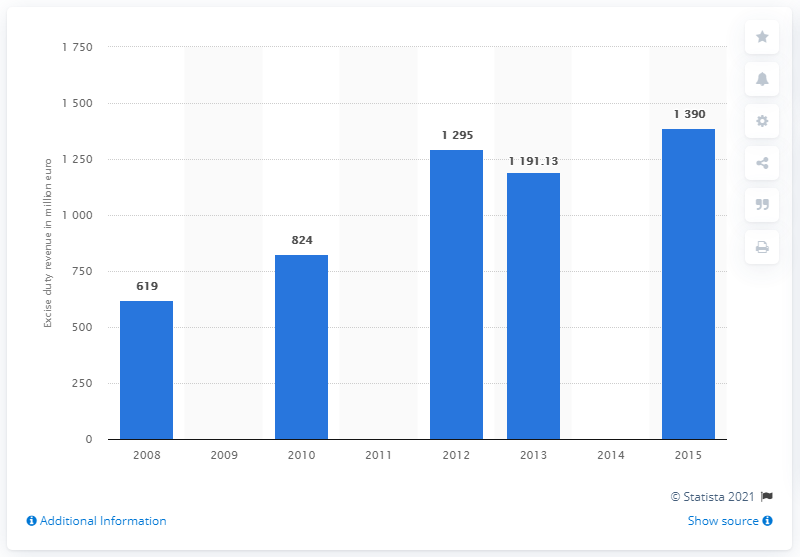Highlight a few significant elements in this photo. In 2015, the revenue generated from Turkey's beer excise duty was 1390. 